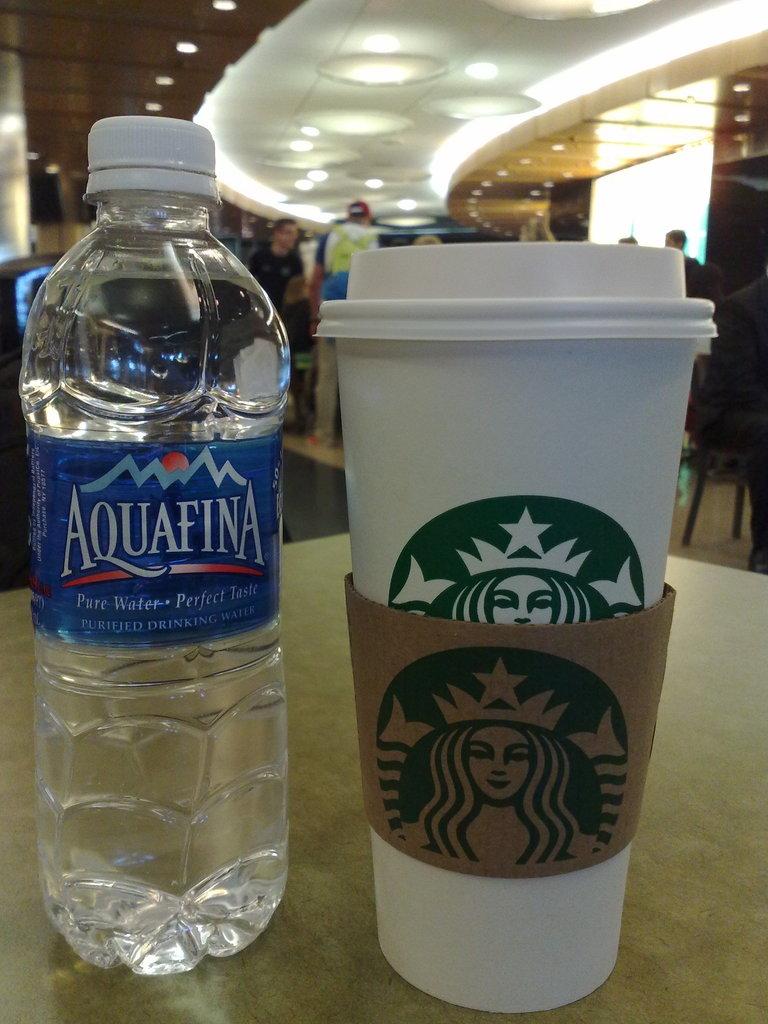Is this water purefied?
Offer a very short reply. Yes. 